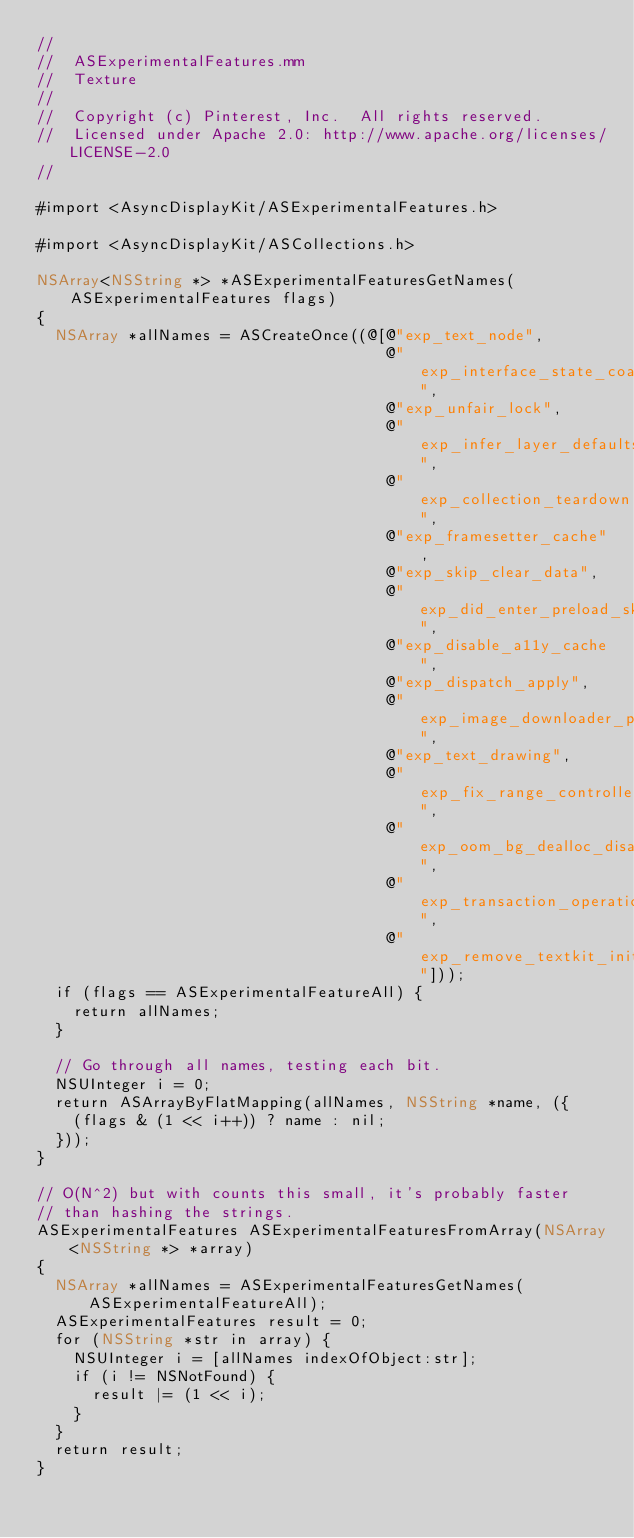<code> <loc_0><loc_0><loc_500><loc_500><_ObjectiveC_>//
//  ASExperimentalFeatures.mm
//  Texture
//
//  Copyright (c) Pinterest, Inc.  All rights reserved.
//  Licensed under Apache 2.0: http://www.apache.org/licenses/LICENSE-2.0
//

#import <AsyncDisplayKit/ASExperimentalFeatures.h>

#import <AsyncDisplayKit/ASCollections.h>

NSArray<NSString *> *ASExperimentalFeaturesGetNames(ASExperimentalFeatures flags)
{
  NSArray *allNames = ASCreateOnce((@[@"exp_text_node",
                                      @"exp_interface_state_coalesce",
                                      @"exp_unfair_lock",
                                      @"exp_infer_layer_defaults",
                                      @"exp_collection_teardown",
                                      @"exp_framesetter_cache",
                                      @"exp_skip_clear_data",
                                      @"exp_did_enter_preload_skip_asm_layout",
                                      @"exp_disable_a11y_cache",
                                      @"exp_dispatch_apply",
                                      @"exp_image_downloader_priority",
                                      @"exp_text_drawing",
                                      @"exp_fix_range_controller",
                                      @"exp_oom_bg_dealloc_disable",
                                      @"exp_transaction_operation_retain_cycle",
                                      @"exp_remove_textkit_initialising_lock"]));
  if (flags == ASExperimentalFeatureAll) {
    return allNames;
  }
  
  // Go through all names, testing each bit.
  NSUInteger i = 0;
  return ASArrayByFlatMapping(allNames, NSString *name, ({
    (flags & (1 << i++)) ? name : nil;
  }));
}

// O(N^2) but with counts this small, it's probably faster
// than hashing the strings.
ASExperimentalFeatures ASExperimentalFeaturesFromArray(NSArray<NSString *> *array)
{
  NSArray *allNames = ASExperimentalFeaturesGetNames(ASExperimentalFeatureAll);
  ASExperimentalFeatures result = 0;
  for (NSString *str in array) {
    NSUInteger i = [allNames indexOfObject:str];
    if (i != NSNotFound) {
      result |= (1 << i);
    }
  }
  return result;
}
</code> 